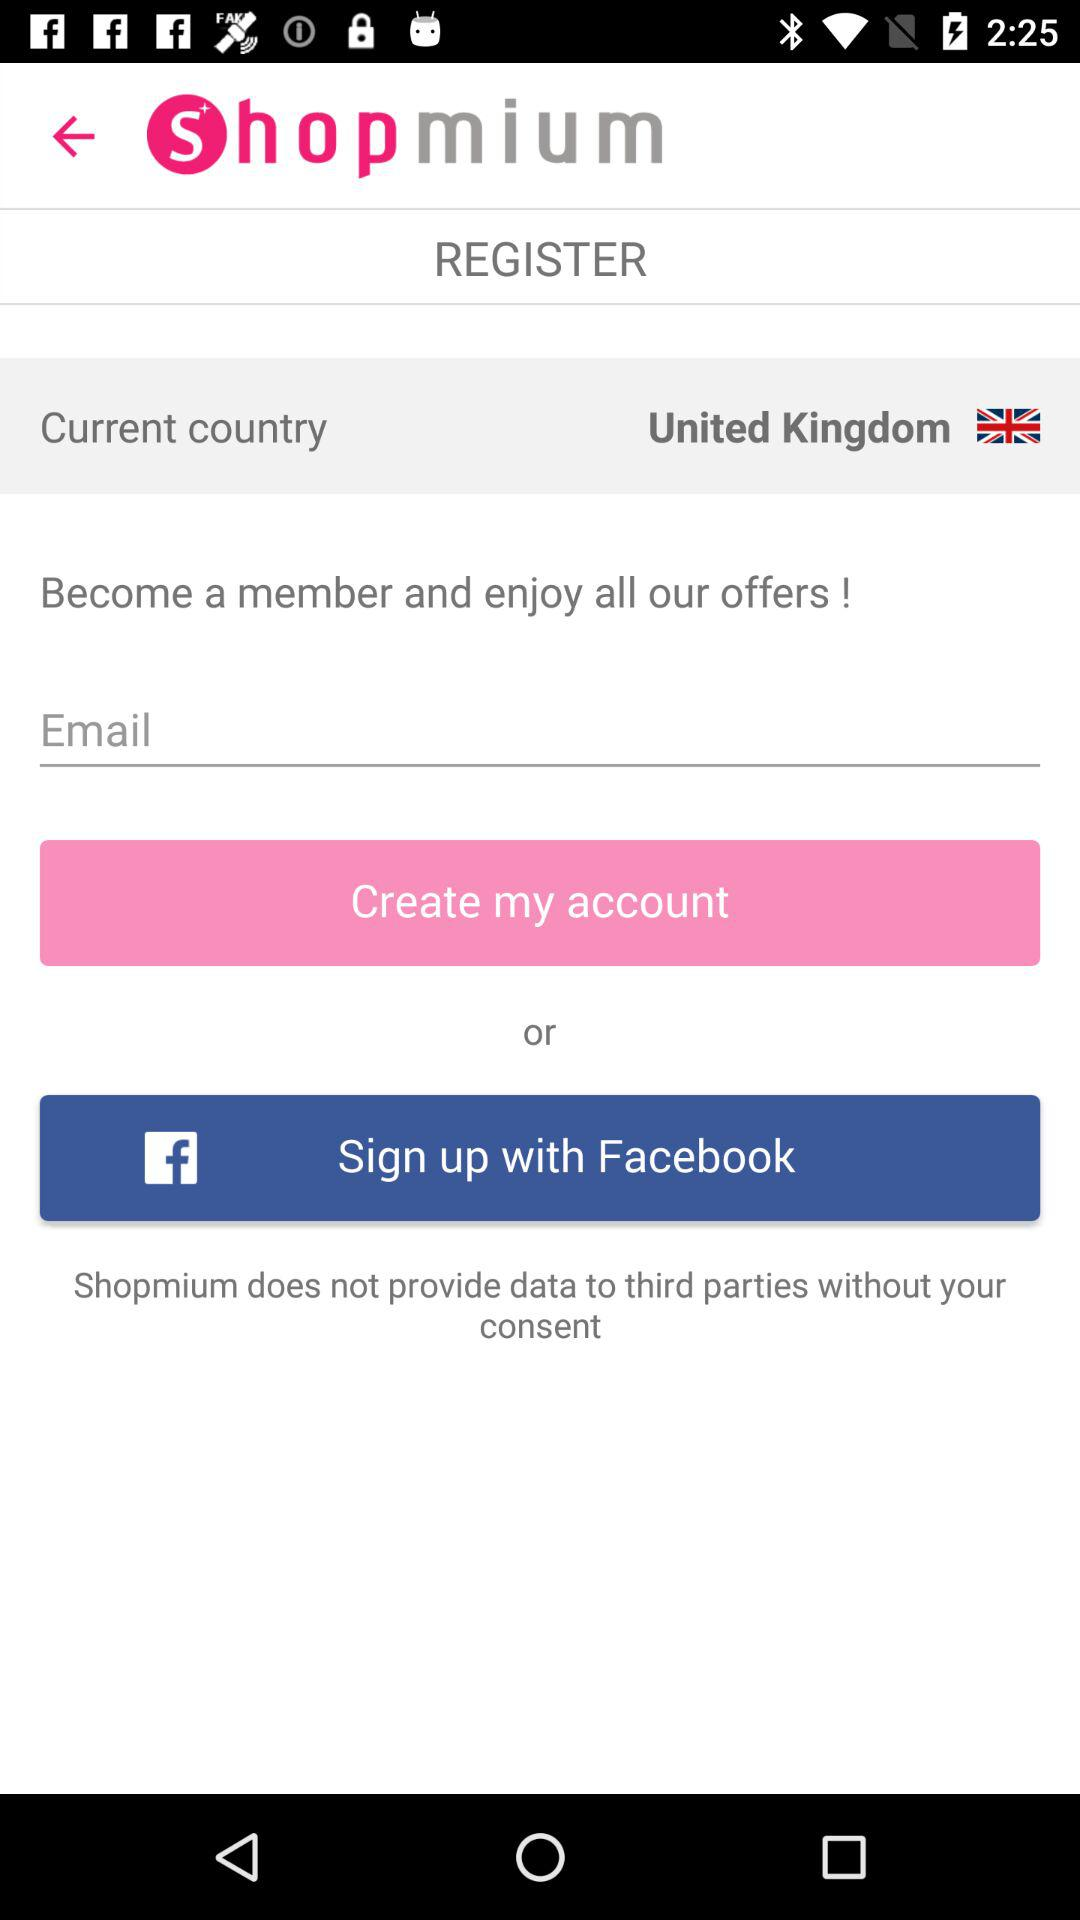What is the selected country? The selected country is the United Kingdom. 